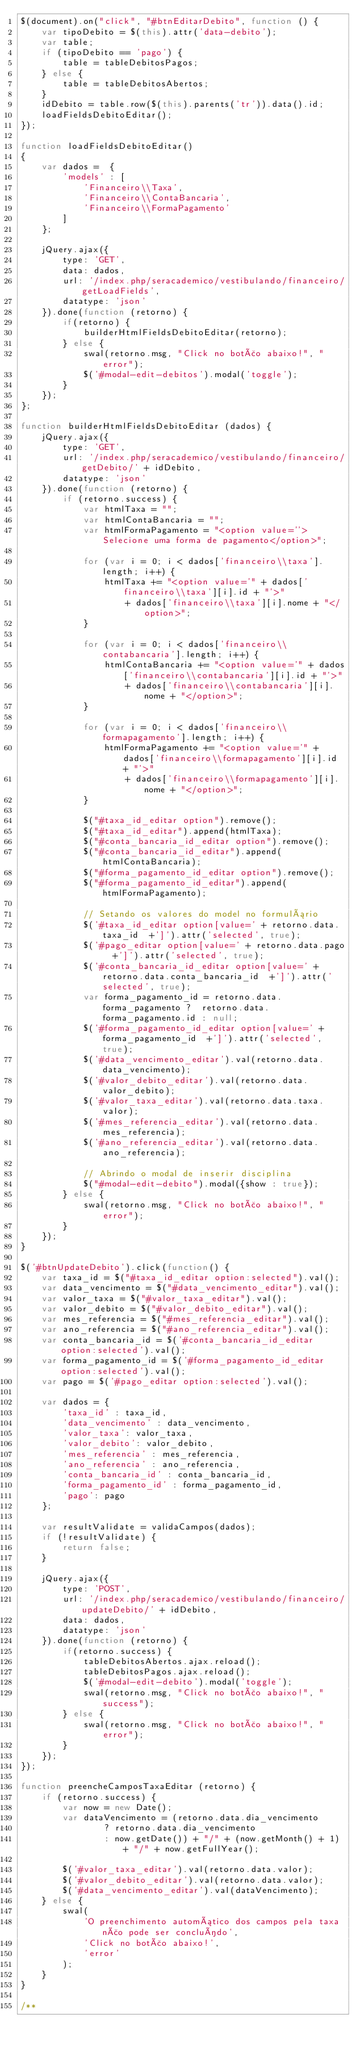Convert code to text. <code><loc_0><loc_0><loc_500><loc_500><_JavaScript_>$(document).on("click", "#btnEditarDebito", function () {
    var tipoDebito = $(this).attr('data-debito');
    var table;
    if (tipoDebito == 'pago') {
        table = tableDebitosPagos;
    } else {
        table = tableDebitosAbertos;
    }
    idDebito = table.row($(this).parents('tr')).data().id;
    loadFieldsDebitoEditar();
});

function loadFieldsDebitoEditar()
{
    var dados =  {
        'models' : [
            'Financeiro\\Taxa',
            'Financeiro\\ContaBancaria',
            'Financeiro\\FormaPagamento'
        ]
    };

    jQuery.ajax({
        type: 'GET',
        data: dados,
        url: '/index.php/seracademico/vestibulando/financeiro/getLoadFields',
        datatype: 'json'
    }).done(function (retorno) {
        if(retorno) {
            builderHtmlFieldsDebitoEditar(retorno);
        } else {
            swal(retorno.msg, "Click no botão abaixo!", "error");
            $('#modal-edit-debitos').modal('toggle');
        }
    });
};

function builderHtmlFieldsDebitoEditar (dados) {
    jQuery.ajax({
        type: 'GET',
        url: '/index.php/seracademico/vestibulando/financeiro/getDebito/' + idDebito,
        datatype: 'json'
    }).done(function (retorno) {
        if (retorno.success) {
            var htmlTaxa = "";
            var htmlContaBancaria = "";
            var htmlFormaPagamento = "<option value=''>Selecione uma forma de pagamento</option>";

            for (var i = 0; i < dados['financeiro\\taxa'].length; i++) {
                htmlTaxa += "<option value='" + dados['financeiro\\taxa'][i].id + "'>"
                    + dados['financeiro\\taxa'][i].nome + "</option>";
            }

            for (var i = 0; i < dados['financeiro\\contabancaria'].length; i++) {
                htmlContaBancaria += "<option value='" + dados['financeiro\\contabancaria'][i].id + "'>"
                    + dados['financeiro\\contabancaria'][i].nome + "</option>";
            }

            for (var i = 0; i < dados['financeiro\\formapagamento'].length; i++) {
                htmlFormaPagamento += "<option value='" + dados['financeiro\\formapagamento'][i].id + "'>"
                    + dados['financeiro\\formapagamento'][i].nome + "</option>";
            }

            $("#taxa_id_editar option").remove();
            $("#taxa_id_editar").append(htmlTaxa);
            $("#conta_bancaria_id_editar option").remove();
            $("#conta_bancaria_id_editar").append(htmlContaBancaria);
            $("#forma_pagamento_id_editar option").remove();
            $("#forma_pagamento_id_editar").append(htmlFormaPagamento);

            // Setando os valores do model no formulário
            $('#taxa_id_editar option[value=' + retorno.data.taxa_id  +']').attr('selected', true);
            $('#pago_editar option[value=' + retorno.data.pago  +']').attr('selected', true);
            $('#conta_bancaria_id_editar option[value=' + retorno.data.conta_bancaria_id  +']').attr('selected', true);
            var forma_pagamento_id = retorno.data.forma_pagamento ?  retorno.data.forma_pagamento.id : null;
            $('#forma_pagamento_id_editar option[value=' + forma_pagamento_id  +']').attr('selected', true);
            $('#data_vencimento_editar').val(retorno.data.data_vencimento);
            $('#valor_debito_editar').val(retorno.data.valor_debito);
            $('#valor_taxa_editar').val(retorno.data.taxa.valor);
            $('#mes_referencia_editar').val(retorno.data.mes_referencia);
            $('#ano_referencia_editar').val(retorno.data.ano_referencia);

            // Abrindo o modal de inserir disciplina
            $("#modal-edit-debito").modal({show : true});
        } else {
            swal(retorno.msg, "Click no botão abaixo!", "error");
        }
    });
}

$('#btnUpdateDebito').click(function() {
    var taxa_id = $("#taxa_id_editar option:selected").val();
    var data_vencimento = $("#data_vencimento_editar").val();
    var valor_taxa = $("#valor_taxa_editar").val();
    var valor_debito = $("#valor_debito_editar").val();
    var mes_referencia = $("#mes_referencia_editar").val();
    var ano_referencia = $("#ano_referencia_editar").val();
    var conta_bancaria_id = $('#conta_bancaria_id_editar option:selected').val();
    var forma_pagamento_id = $('#forma_pagamento_id_editar option:selected').val();
    var pago = $('#pago_editar option:selected').val();

    var dados = {
        'taxa_id' : taxa_id,
        'data_vencimento' : data_vencimento,
        'valor_taxa': valor_taxa,
        'valor_debito': valor_debito,
        'mes_referencia' : mes_referencia,
        'ano_referencia' : ano_referencia,
        'conta_bancaria_id' : conta_bancaria_id,
        'forma_pagamento_id' : forma_pagamento_id,
        'pago': pago
    };

    var resultValidate = validaCampos(dados);
    if (!resultValidate) {
        return false;
    }

    jQuery.ajax({
        type: 'POST',
        url: '/index.php/seracademico/vestibulando/financeiro/updateDebito/' + idDebito,
        data: dados,
        datatype: 'json'
    }).done(function (retorno) {
        if(retorno.success) {
            tableDebitosAbertos.ajax.reload();
            tableDebitosPagos.ajax.reload();
            $('#modal-edit-debito').modal('toggle');
            swal(retorno.msg, "Click no botão abaixo!", "success");
        } else {
            swal(retorno.msg, "Click no botão abaixo!", "error");
        }
    });
});

function preencheCamposTaxaEditar (retorno) {
    if (retorno.success) {
        var now = new Date();
        var dataVencimento = (retorno.data.dia_vencimento
                ? retorno.data.dia_vencimento
                : now.getDate()) + "/" + (now.getMonth() + 1) + "/" + now.getFullYear();

        $('#valor_taxa_editar').val(retorno.data.valor);
        $('#valor_debito_editar').val(retorno.data.valor);
        $('#data_vencimento_editar').val(dataVencimento);
    } else {
        swal(
            'O preenchimento automático dos campos pela taxa não pode ser concluído',
            'Click no botão abaixo!',
            'error'
        );
    }
}

/**</code> 